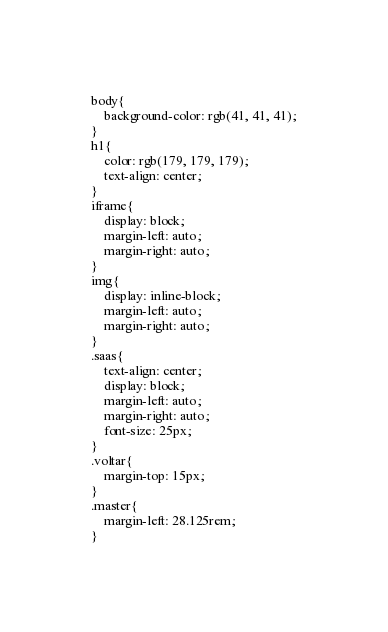Convert code to text. <code><loc_0><loc_0><loc_500><loc_500><_CSS_>body{
    background-color: rgb(41, 41, 41);
}
h1{
    color: rgb(179, 179, 179);
    text-align: center;
}
iframe{
    display: block;
    margin-left: auto;
    margin-right: auto;
}
img{
    display: inline-block;
    margin-left: auto;
    margin-right: auto; 
}
.saas{
    text-align: center;
    display: block;
    margin-left: auto;
    margin-right: auto;
    font-size: 25px;
}
.voltar{
    margin-top: 15px;
}
.master{
    margin-left: 28.125rem;
}</code> 